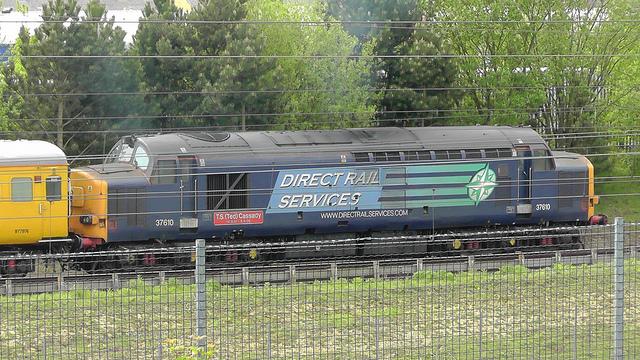What language is on the train?
Be succinct. English. Is the train moving?
Answer briefly. Yes. What color is the word "direct" on the side of the train?
Write a very short answer. White. 